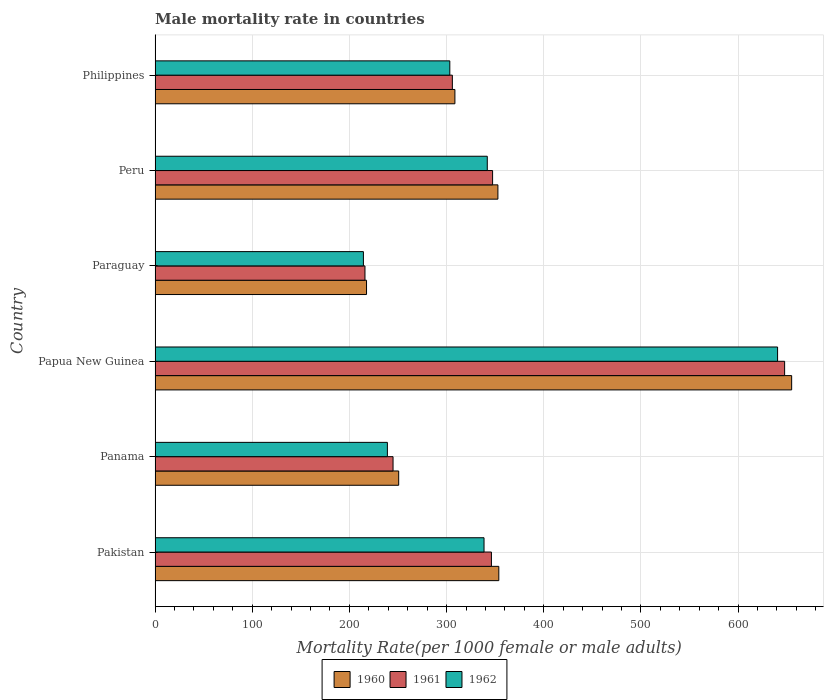How many groups of bars are there?
Make the answer very short. 6. Are the number of bars per tick equal to the number of legend labels?
Ensure brevity in your answer.  Yes. Are the number of bars on each tick of the Y-axis equal?
Give a very brief answer. Yes. What is the label of the 5th group of bars from the top?
Offer a terse response. Panama. What is the male mortality rate in 1960 in Peru?
Make the answer very short. 352.84. Across all countries, what is the maximum male mortality rate in 1961?
Keep it short and to the point. 647.91. Across all countries, what is the minimum male mortality rate in 1960?
Your response must be concise. 217.64. In which country was the male mortality rate in 1961 maximum?
Keep it short and to the point. Papua New Guinea. In which country was the male mortality rate in 1962 minimum?
Make the answer very short. Paraguay. What is the total male mortality rate in 1961 in the graph?
Your response must be concise. 2108.36. What is the difference between the male mortality rate in 1961 in Paraguay and that in Peru?
Offer a terse response. -131.34. What is the difference between the male mortality rate in 1961 in Panama and the male mortality rate in 1960 in Philippines?
Make the answer very short. -63.66. What is the average male mortality rate in 1960 per country?
Your answer should be very brief. 356.45. What is the difference between the male mortality rate in 1962 and male mortality rate in 1961 in Panama?
Your answer should be very brief. -5.82. In how many countries, is the male mortality rate in 1962 greater than 580 ?
Offer a very short reply. 1. What is the ratio of the male mortality rate in 1960 in Panama to that in Paraguay?
Offer a very short reply. 1.15. Is the male mortality rate in 1962 in Peru less than that in Philippines?
Your answer should be very brief. No. Is the difference between the male mortality rate in 1962 in Pakistan and Philippines greater than the difference between the male mortality rate in 1961 in Pakistan and Philippines?
Provide a short and direct response. No. What is the difference between the highest and the second highest male mortality rate in 1960?
Provide a succinct answer. 301.39. What is the difference between the highest and the lowest male mortality rate in 1962?
Provide a short and direct response. 426.24. Is the sum of the male mortality rate in 1962 in Paraguay and Philippines greater than the maximum male mortality rate in 1961 across all countries?
Your answer should be very brief. No. How many bars are there?
Ensure brevity in your answer.  18. Are all the bars in the graph horizontal?
Offer a very short reply. Yes. What is the difference between two consecutive major ticks on the X-axis?
Keep it short and to the point. 100. Are the values on the major ticks of X-axis written in scientific E-notation?
Your answer should be very brief. No. Does the graph contain grids?
Make the answer very short. Yes. How many legend labels are there?
Your answer should be compact. 3. How are the legend labels stacked?
Make the answer very short. Horizontal. What is the title of the graph?
Your response must be concise. Male mortality rate in countries. Does "2013" appear as one of the legend labels in the graph?
Offer a very short reply. No. What is the label or title of the X-axis?
Give a very brief answer. Mortality Rate(per 1000 female or male adults). What is the label or title of the Y-axis?
Keep it short and to the point. Country. What is the Mortality Rate(per 1000 female or male adults) of 1960 in Pakistan?
Offer a very short reply. 353.77. What is the Mortality Rate(per 1000 female or male adults) of 1961 in Pakistan?
Give a very brief answer. 346.17. What is the Mortality Rate(per 1000 female or male adults) of 1962 in Pakistan?
Offer a very short reply. 338.56. What is the Mortality Rate(per 1000 female or male adults) in 1960 in Panama?
Ensure brevity in your answer.  250.73. What is the Mortality Rate(per 1000 female or male adults) in 1961 in Panama?
Keep it short and to the point. 244.92. What is the Mortality Rate(per 1000 female or male adults) of 1962 in Panama?
Your response must be concise. 239.1. What is the Mortality Rate(per 1000 female or male adults) of 1960 in Papua New Guinea?
Offer a very short reply. 655.16. What is the Mortality Rate(per 1000 female or male adults) of 1961 in Papua New Guinea?
Provide a succinct answer. 647.91. What is the Mortality Rate(per 1000 female or male adults) in 1962 in Papua New Guinea?
Provide a succinct answer. 640.66. What is the Mortality Rate(per 1000 female or male adults) of 1960 in Paraguay?
Offer a very short reply. 217.64. What is the Mortality Rate(per 1000 female or male adults) of 1961 in Paraguay?
Give a very brief answer. 216.03. What is the Mortality Rate(per 1000 female or male adults) of 1962 in Paraguay?
Make the answer very short. 214.42. What is the Mortality Rate(per 1000 female or male adults) in 1960 in Peru?
Offer a very short reply. 352.84. What is the Mortality Rate(per 1000 female or male adults) in 1961 in Peru?
Your answer should be very brief. 347.37. What is the Mortality Rate(per 1000 female or male adults) in 1962 in Peru?
Ensure brevity in your answer.  341.9. What is the Mortality Rate(per 1000 female or male adults) of 1960 in Philippines?
Your answer should be compact. 308.58. What is the Mortality Rate(per 1000 female or male adults) in 1961 in Philippines?
Provide a short and direct response. 305.97. What is the Mortality Rate(per 1000 female or male adults) in 1962 in Philippines?
Provide a succinct answer. 303.35. Across all countries, what is the maximum Mortality Rate(per 1000 female or male adults) of 1960?
Ensure brevity in your answer.  655.16. Across all countries, what is the maximum Mortality Rate(per 1000 female or male adults) of 1961?
Provide a succinct answer. 647.91. Across all countries, what is the maximum Mortality Rate(per 1000 female or male adults) in 1962?
Your answer should be very brief. 640.66. Across all countries, what is the minimum Mortality Rate(per 1000 female or male adults) in 1960?
Offer a terse response. 217.64. Across all countries, what is the minimum Mortality Rate(per 1000 female or male adults) in 1961?
Your response must be concise. 216.03. Across all countries, what is the minimum Mortality Rate(per 1000 female or male adults) in 1962?
Your answer should be very brief. 214.42. What is the total Mortality Rate(per 1000 female or male adults) in 1960 in the graph?
Your response must be concise. 2138.72. What is the total Mortality Rate(per 1000 female or male adults) in 1961 in the graph?
Offer a very short reply. 2108.36. What is the total Mortality Rate(per 1000 female or male adults) in 1962 in the graph?
Offer a very short reply. 2078. What is the difference between the Mortality Rate(per 1000 female or male adults) in 1960 in Pakistan and that in Panama?
Your answer should be compact. 103.04. What is the difference between the Mortality Rate(per 1000 female or male adults) in 1961 in Pakistan and that in Panama?
Give a very brief answer. 101.25. What is the difference between the Mortality Rate(per 1000 female or male adults) in 1962 in Pakistan and that in Panama?
Offer a very short reply. 99.46. What is the difference between the Mortality Rate(per 1000 female or male adults) of 1960 in Pakistan and that in Papua New Guinea?
Provide a short and direct response. -301.39. What is the difference between the Mortality Rate(per 1000 female or male adults) of 1961 in Pakistan and that in Papua New Guinea?
Keep it short and to the point. -301.74. What is the difference between the Mortality Rate(per 1000 female or male adults) in 1962 in Pakistan and that in Papua New Guinea?
Make the answer very short. -302.1. What is the difference between the Mortality Rate(per 1000 female or male adults) of 1960 in Pakistan and that in Paraguay?
Your answer should be compact. 136.13. What is the difference between the Mortality Rate(per 1000 female or male adults) in 1961 in Pakistan and that in Paraguay?
Your answer should be very brief. 130.13. What is the difference between the Mortality Rate(per 1000 female or male adults) in 1962 in Pakistan and that in Paraguay?
Your response must be concise. 124.14. What is the difference between the Mortality Rate(per 1000 female or male adults) of 1960 in Pakistan and that in Peru?
Ensure brevity in your answer.  0.93. What is the difference between the Mortality Rate(per 1000 female or male adults) in 1961 in Pakistan and that in Peru?
Your answer should be very brief. -1.2. What is the difference between the Mortality Rate(per 1000 female or male adults) of 1962 in Pakistan and that in Peru?
Ensure brevity in your answer.  -3.33. What is the difference between the Mortality Rate(per 1000 female or male adults) of 1960 in Pakistan and that in Philippines?
Provide a succinct answer. 45.19. What is the difference between the Mortality Rate(per 1000 female or male adults) of 1961 in Pakistan and that in Philippines?
Offer a very short reply. 40.2. What is the difference between the Mortality Rate(per 1000 female or male adults) in 1962 in Pakistan and that in Philippines?
Offer a very short reply. 35.21. What is the difference between the Mortality Rate(per 1000 female or male adults) of 1960 in Panama and that in Papua New Guinea?
Your answer should be compact. -404.42. What is the difference between the Mortality Rate(per 1000 female or male adults) of 1961 in Panama and that in Papua New Guinea?
Offer a very short reply. -402.99. What is the difference between the Mortality Rate(per 1000 female or male adults) of 1962 in Panama and that in Papua New Guinea?
Provide a short and direct response. -401.56. What is the difference between the Mortality Rate(per 1000 female or male adults) in 1960 in Panama and that in Paraguay?
Your answer should be compact. 33.09. What is the difference between the Mortality Rate(per 1000 female or male adults) of 1961 in Panama and that in Paraguay?
Your response must be concise. 28.89. What is the difference between the Mortality Rate(per 1000 female or male adults) of 1962 in Panama and that in Paraguay?
Give a very brief answer. 24.68. What is the difference between the Mortality Rate(per 1000 female or male adults) of 1960 in Panama and that in Peru?
Your answer should be compact. -102.1. What is the difference between the Mortality Rate(per 1000 female or male adults) of 1961 in Panama and that in Peru?
Offer a terse response. -102.45. What is the difference between the Mortality Rate(per 1000 female or male adults) in 1962 in Panama and that in Peru?
Ensure brevity in your answer.  -102.79. What is the difference between the Mortality Rate(per 1000 female or male adults) of 1960 in Panama and that in Philippines?
Offer a very short reply. -57.85. What is the difference between the Mortality Rate(per 1000 female or male adults) of 1961 in Panama and that in Philippines?
Provide a succinct answer. -61.05. What is the difference between the Mortality Rate(per 1000 female or male adults) of 1962 in Panama and that in Philippines?
Your answer should be compact. -64.25. What is the difference between the Mortality Rate(per 1000 female or male adults) in 1960 in Papua New Guinea and that in Paraguay?
Provide a short and direct response. 437.52. What is the difference between the Mortality Rate(per 1000 female or male adults) in 1961 in Papua New Guinea and that in Paraguay?
Keep it short and to the point. 431.88. What is the difference between the Mortality Rate(per 1000 female or male adults) in 1962 in Papua New Guinea and that in Paraguay?
Your response must be concise. 426.24. What is the difference between the Mortality Rate(per 1000 female or male adults) of 1960 in Papua New Guinea and that in Peru?
Make the answer very short. 302.32. What is the difference between the Mortality Rate(per 1000 female or male adults) of 1961 in Papua New Guinea and that in Peru?
Keep it short and to the point. 300.54. What is the difference between the Mortality Rate(per 1000 female or male adults) in 1962 in Papua New Guinea and that in Peru?
Provide a short and direct response. 298.77. What is the difference between the Mortality Rate(per 1000 female or male adults) in 1960 in Papua New Guinea and that in Philippines?
Offer a terse response. 346.57. What is the difference between the Mortality Rate(per 1000 female or male adults) in 1961 in Papua New Guinea and that in Philippines?
Give a very brief answer. 341.94. What is the difference between the Mortality Rate(per 1000 female or male adults) of 1962 in Papua New Guinea and that in Philippines?
Keep it short and to the point. 337.31. What is the difference between the Mortality Rate(per 1000 female or male adults) of 1960 in Paraguay and that in Peru?
Ensure brevity in your answer.  -135.2. What is the difference between the Mortality Rate(per 1000 female or male adults) of 1961 in Paraguay and that in Peru?
Your answer should be very brief. -131.34. What is the difference between the Mortality Rate(per 1000 female or male adults) of 1962 in Paraguay and that in Peru?
Offer a terse response. -127.48. What is the difference between the Mortality Rate(per 1000 female or male adults) of 1960 in Paraguay and that in Philippines?
Ensure brevity in your answer.  -90.94. What is the difference between the Mortality Rate(per 1000 female or male adults) of 1961 in Paraguay and that in Philippines?
Your answer should be very brief. -89.94. What is the difference between the Mortality Rate(per 1000 female or male adults) of 1962 in Paraguay and that in Philippines?
Your answer should be very brief. -88.93. What is the difference between the Mortality Rate(per 1000 female or male adults) of 1960 in Peru and that in Philippines?
Offer a very short reply. 44.26. What is the difference between the Mortality Rate(per 1000 female or male adults) of 1961 in Peru and that in Philippines?
Keep it short and to the point. 41.4. What is the difference between the Mortality Rate(per 1000 female or male adults) in 1962 in Peru and that in Philippines?
Your answer should be compact. 38.55. What is the difference between the Mortality Rate(per 1000 female or male adults) of 1960 in Pakistan and the Mortality Rate(per 1000 female or male adults) of 1961 in Panama?
Provide a short and direct response. 108.85. What is the difference between the Mortality Rate(per 1000 female or male adults) in 1960 in Pakistan and the Mortality Rate(per 1000 female or male adults) in 1962 in Panama?
Provide a succinct answer. 114.67. What is the difference between the Mortality Rate(per 1000 female or male adults) of 1961 in Pakistan and the Mortality Rate(per 1000 female or male adults) of 1962 in Panama?
Offer a terse response. 107.06. What is the difference between the Mortality Rate(per 1000 female or male adults) in 1960 in Pakistan and the Mortality Rate(per 1000 female or male adults) in 1961 in Papua New Guinea?
Provide a succinct answer. -294.14. What is the difference between the Mortality Rate(per 1000 female or male adults) of 1960 in Pakistan and the Mortality Rate(per 1000 female or male adults) of 1962 in Papua New Guinea?
Give a very brief answer. -286.89. What is the difference between the Mortality Rate(per 1000 female or male adults) of 1961 in Pakistan and the Mortality Rate(per 1000 female or male adults) of 1962 in Papua New Guinea?
Your answer should be compact. -294.5. What is the difference between the Mortality Rate(per 1000 female or male adults) in 1960 in Pakistan and the Mortality Rate(per 1000 female or male adults) in 1961 in Paraguay?
Offer a very short reply. 137.74. What is the difference between the Mortality Rate(per 1000 female or male adults) in 1960 in Pakistan and the Mortality Rate(per 1000 female or male adults) in 1962 in Paraguay?
Your response must be concise. 139.35. What is the difference between the Mortality Rate(per 1000 female or male adults) in 1961 in Pakistan and the Mortality Rate(per 1000 female or male adults) in 1962 in Paraguay?
Make the answer very short. 131.75. What is the difference between the Mortality Rate(per 1000 female or male adults) of 1960 in Pakistan and the Mortality Rate(per 1000 female or male adults) of 1961 in Peru?
Offer a terse response. 6.4. What is the difference between the Mortality Rate(per 1000 female or male adults) in 1960 in Pakistan and the Mortality Rate(per 1000 female or male adults) in 1962 in Peru?
Offer a terse response. 11.87. What is the difference between the Mortality Rate(per 1000 female or male adults) in 1961 in Pakistan and the Mortality Rate(per 1000 female or male adults) in 1962 in Peru?
Your answer should be very brief. 4.27. What is the difference between the Mortality Rate(per 1000 female or male adults) in 1960 in Pakistan and the Mortality Rate(per 1000 female or male adults) in 1961 in Philippines?
Your answer should be very brief. 47.8. What is the difference between the Mortality Rate(per 1000 female or male adults) in 1960 in Pakistan and the Mortality Rate(per 1000 female or male adults) in 1962 in Philippines?
Provide a short and direct response. 50.42. What is the difference between the Mortality Rate(per 1000 female or male adults) in 1961 in Pakistan and the Mortality Rate(per 1000 female or male adults) in 1962 in Philippines?
Ensure brevity in your answer.  42.81. What is the difference between the Mortality Rate(per 1000 female or male adults) of 1960 in Panama and the Mortality Rate(per 1000 female or male adults) of 1961 in Papua New Guinea?
Keep it short and to the point. -397.18. What is the difference between the Mortality Rate(per 1000 female or male adults) of 1960 in Panama and the Mortality Rate(per 1000 female or male adults) of 1962 in Papua New Guinea?
Provide a succinct answer. -389.93. What is the difference between the Mortality Rate(per 1000 female or male adults) of 1961 in Panama and the Mortality Rate(per 1000 female or male adults) of 1962 in Papua New Guinea?
Ensure brevity in your answer.  -395.74. What is the difference between the Mortality Rate(per 1000 female or male adults) in 1960 in Panama and the Mortality Rate(per 1000 female or male adults) in 1961 in Paraguay?
Give a very brief answer. 34.7. What is the difference between the Mortality Rate(per 1000 female or male adults) in 1960 in Panama and the Mortality Rate(per 1000 female or male adults) in 1962 in Paraguay?
Your response must be concise. 36.31. What is the difference between the Mortality Rate(per 1000 female or male adults) of 1961 in Panama and the Mortality Rate(per 1000 female or male adults) of 1962 in Paraguay?
Make the answer very short. 30.5. What is the difference between the Mortality Rate(per 1000 female or male adults) of 1960 in Panama and the Mortality Rate(per 1000 female or male adults) of 1961 in Peru?
Your answer should be compact. -96.63. What is the difference between the Mortality Rate(per 1000 female or male adults) in 1960 in Panama and the Mortality Rate(per 1000 female or male adults) in 1962 in Peru?
Offer a very short reply. -91.16. What is the difference between the Mortality Rate(per 1000 female or male adults) in 1961 in Panama and the Mortality Rate(per 1000 female or male adults) in 1962 in Peru?
Your answer should be compact. -96.98. What is the difference between the Mortality Rate(per 1000 female or male adults) in 1960 in Panama and the Mortality Rate(per 1000 female or male adults) in 1961 in Philippines?
Provide a succinct answer. -55.23. What is the difference between the Mortality Rate(per 1000 female or male adults) in 1960 in Panama and the Mortality Rate(per 1000 female or male adults) in 1962 in Philippines?
Ensure brevity in your answer.  -52.62. What is the difference between the Mortality Rate(per 1000 female or male adults) in 1961 in Panama and the Mortality Rate(per 1000 female or male adults) in 1962 in Philippines?
Offer a very short reply. -58.43. What is the difference between the Mortality Rate(per 1000 female or male adults) in 1960 in Papua New Guinea and the Mortality Rate(per 1000 female or male adults) in 1961 in Paraguay?
Ensure brevity in your answer.  439.13. What is the difference between the Mortality Rate(per 1000 female or male adults) of 1960 in Papua New Guinea and the Mortality Rate(per 1000 female or male adults) of 1962 in Paraguay?
Your response must be concise. 440.74. What is the difference between the Mortality Rate(per 1000 female or male adults) of 1961 in Papua New Guinea and the Mortality Rate(per 1000 female or male adults) of 1962 in Paraguay?
Keep it short and to the point. 433.49. What is the difference between the Mortality Rate(per 1000 female or male adults) of 1960 in Papua New Guinea and the Mortality Rate(per 1000 female or male adults) of 1961 in Peru?
Keep it short and to the point. 307.79. What is the difference between the Mortality Rate(per 1000 female or male adults) in 1960 in Papua New Guinea and the Mortality Rate(per 1000 female or male adults) in 1962 in Peru?
Your answer should be compact. 313.26. What is the difference between the Mortality Rate(per 1000 female or male adults) of 1961 in Papua New Guinea and the Mortality Rate(per 1000 female or male adults) of 1962 in Peru?
Your answer should be compact. 306.01. What is the difference between the Mortality Rate(per 1000 female or male adults) of 1960 in Papua New Guinea and the Mortality Rate(per 1000 female or male adults) of 1961 in Philippines?
Your answer should be compact. 349.19. What is the difference between the Mortality Rate(per 1000 female or male adults) in 1960 in Papua New Guinea and the Mortality Rate(per 1000 female or male adults) in 1962 in Philippines?
Provide a short and direct response. 351.81. What is the difference between the Mortality Rate(per 1000 female or male adults) of 1961 in Papua New Guinea and the Mortality Rate(per 1000 female or male adults) of 1962 in Philippines?
Offer a very short reply. 344.56. What is the difference between the Mortality Rate(per 1000 female or male adults) of 1960 in Paraguay and the Mortality Rate(per 1000 female or male adults) of 1961 in Peru?
Provide a short and direct response. -129.73. What is the difference between the Mortality Rate(per 1000 female or male adults) of 1960 in Paraguay and the Mortality Rate(per 1000 female or male adults) of 1962 in Peru?
Ensure brevity in your answer.  -124.26. What is the difference between the Mortality Rate(per 1000 female or male adults) in 1961 in Paraguay and the Mortality Rate(per 1000 female or male adults) in 1962 in Peru?
Your answer should be very brief. -125.87. What is the difference between the Mortality Rate(per 1000 female or male adults) of 1960 in Paraguay and the Mortality Rate(per 1000 female or male adults) of 1961 in Philippines?
Your response must be concise. -88.33. What is the difference between the Mortality Rate(per 1000 female or male adults) in 1960 in Paraguay and the Mortality Rate(per 1000 female or male adults) in 1962 in Philippines?
Offer a very short reply. -85.71. What is the difference between the Mortality Rate(per 1000 female or male adults) of 1961 in Paraguay and the Mortality Rate(per 1000 female or male adults) of 1962 in Philippines?
Make the answer very short. -87.32. What is the difference between the Mortality Rate(per 1000 female or male adults) in 1960 in Peru and the Mortality Rate(per 1000 female or male adults) in 1961 in Philippines?
Offer a very short reply. 46.87. What is the difference between the Mortality Rate(per 1000 female or male adults) of 1960 in Peru and the Mortality Rate(per 1000 female or male adults) of 1962 in Philippines?
Provide a short and direct response. 49.49. What is the difference between the Mortality Rate(per 1000 female or male adults) of 1961 in Peru and the Mortality Rate(per 1000 female or male adults) of 1962 in Philippines?
Offer a very short reply. 44.02. What is the average Mortality Rate(per 1000 female or male adults) of 1960 per country?
Your answer should be very brief. 356.45. What is the average Mortality Rate(per 1000 female or male adults) of 1961 per country?
Provide a succinct answer. 351.39. What is the average Mortality Rate(per 1000 female or male adults) in 1962 per country?
Make the answer very short. 346.33. What is the difference between the Mortality Rate(per 1000 female or male adults) in 1960 and Mortality Rate(per 1000 female or male adults) in 1961 in Pakistan?
Ensure brevity in your answer.  7.61. What is the difference between the Mortality Rate(per 1000 female or male adults) in 1960 and Mortality Rate(per 1000 female or male adults) in 1962 in Pakistan?
Provide a succinct answer. 15.21. What is the difference between the Mortality Rate(per 1000 female or male adults) of 1961 and Mortality Rate(per 1000 female or male adults) of 1962 in Pakistan?
Offer a very short reply. 7.6. What is the difference between the Mortality Rate(per 1000 female or male adults) of 1960 and Mortality Rate(per 1000 female or male adults) of 1961 in Panama?
Make the answer very short. 5.82. What is the difference between the Mortality Rate(per 1000 female or male adults) of 1960 and Mortality Rate(per 1000 female or male adults) of 1962 in Panama?
Your response must be concise. 11.63. What is the difference between the Mortality Rate(per 1000 female or male adults) in 1961 and Mortality Rate(per 1000 female or male adults) in 1962 in Panama?
Offer a very short reply. 5.82. What is the difference between the Mortality Rate(per 1000 female or male adults) of 1960 and Mortality Rate(per 1000 female or male adults) of 1961 in Papua New Guinea?
Make the answer very short. 7.25. What is the difference between the Mortality Rate(per 1000 female or male adults) in 1960 and Mortality Rate(per 1000 female or male adults) in 1962 in Papua New Guinea?
Your answer should be very brief. 14.49. What is the difference between the Mortality Rate(per 1000 female or male adults) in 1961 and Mortality Rate(per 1000 female or male adults) in 1962 in Papua New Guinea?
Provide a succinct answer. 7.25. What is the difference between the Mortality Rate(per 1000 female or male adults) of 1960 and Mortality Rate(per 1000 female or male adults) of 1961 in Paraguay?
Ensure brevity in your answer.  1.61. What is the difference between the Mortality Rate(per 1000 female or male adults) in 1960 and Mortality Rate(per 1000 female or male adults) in 1962 in Paraguay?
Keep it short and to the point. 3.22. What is the difference between the Mortality Rate(per 1000 female or male adults) of 1961 and Mortality Rate(per 1000 female or male adults) of 1962 in Paraguay?
Provide a short and direct response. 1.61. What is the difference between the Mortality Rate(per 1000 female or male adults) in 1960 and Mortality Rate(per 1000 female or male adults) in 1961 in Peru?
Your answer should be very brief. 5.47. What is the difference between the Mortality Rate(per 1000 female or male adults) of 1960 and Mortality Rate(per 1000 female or male adults) of 1962 in Peru?
Keep it short and to the point. 10.94. What is the difference between the Mortality Rate(per 1000 female or male adults) in 1961 and Mortality Rate(per 1000 female or male adults) in 1962 in Peru?
Keep it short and to the point. 5.47. What is the difference between the Mortality Rate(per 1000 female or male adults) in 1960 and Mortality Rate(per 1000 female or male adults) in 1961 in Philippines?
Ensure brevity in your answer.  2.62. What is the difference between the Mortality Rate(per 1000 female or male adults) of 1960 and Mortality Rate(per 1000 female or male adults) of 1962 in Philippines?
Give a very brief answer. 5.23. What is the difference between the Mortality Rate(per 1000 female or male adults) in 1961 and Mortality Rate(per 1000 female or male adults) in 1962 in Philippines?
Your response must be concise. 2.62. What is the ratio of the Mortality Rate(per 1000 female or male adults) in 1960 in Pakistan to that in Panama?
Make the answer very short. 1.41. What is the ratio of the Mortality Rate(per 1000 female or male adults) in 1961 in Pakistan to that in Panama?
Your answer should be compact. 1.41. What is the ratio of the Mortality Rate(per 1000 female or male adults) of 1962 in Pakistan to that in Panama?
Provide a succinct answer. 1.42. What is the ratio of the Mortality Rate(per 1000 female or male adults) of 1960 in Pakistan to that in Papua New Guinea?
Keep it short and to the point. 0.54. What is the ratio of the Mortality Rate(per 1000 female or male adults) in 1961 in Pakistan to that in Papua New Guinea?
Ensure brevity in your answer.  0.53. What is the ratio of the Mortality Rate(per 1000 female or male adults) of 1962 in Pakistan to that in Papua New Guinea?
Your answer should be very brief. 0.53. What is the ratio of the Mortality Rate(per 1000 female or male adults) of 1960 in Pakistan to that in Paraguay?
Your answer should be very brief. 1.63. What is the ratio of the Mortality Rate(per 1000 female or male adults) in 1961 in Pakistan to that in Paraguay?
Your answer should be compact. 1.6. What is the ratio of the Mortality Rate(per 1000 female or male adults) in 1962 in Pakistan to that in Paraguay?
Your answer should be very brief. 1.58. What is the ratio of the Mortality Rate(per 1000 female or male adults) of 1960 in Pakistan to that in Peru?
Give a very brief answer. 1. What is the ratio of the Mortality Rate(per 1000 female or male adults) in 1962 in Pakistan to that in Peru?
Offer a terse response. 0.99. What is the ratio of the Mortality Rate(per 1000 female or male adults) in 1960 in Pakistan to that in Philippines?
Offer a very short reply. 1.15. What is the ratio of the Mortality Rate(per 1000 female or male adults) of 1961 in Pakistan to that in Philippines?
Your answer should be compact. 1.13. What is the ratio of the Mortality Rate(per 1000 female or male adults) of 1962 in Pakistan to that in Philippines?
Make the answer very short. 1.12. What is the ratio of the Mortality Rate(per 1000 female or male adults) in 1960 in Panama to that in Papua New Guinea?
Give a very brief answer. 0.38. What is the ratio of the Mortality Rate(per 1000 female or male adults) in 1961 in Panama to that in Papua New Guinea?
Make the answer very short. 0.38. What is the ratio of the Mortality Rate(per 1000 female or male adults) in 1962 in Panama to that in Papua New Guinea?
Your answer should be compact. 0.37. What is the ratio of the Mortality Rate(per 1000 female or male adults) in 1960 in Panama to that in Paraguay?
Offer a very short reply. 1.15. What is the ratio of the Mortality Rate(per 1000 female or male adults) in 1961 in Panama to that in Paraguay?
Offer a terse response. 1.13. What is the ratio of the Mortality Rate(per 1000 female or male adults) of 1962 in Panama to that in Paraguay?
Your answer should be very brief. 1.12. What is the ratio of the Mortality Rate(per 1000 female or male adults) in 1960 in Panama to that in Peru?
Give a very brief answer. 0.71. What is the ratio of the Mortality Rate(per 1000 female or male adults) of 1961 in Panama to that in Peru?
Make the answer very short. 0.71. What is the ratio of the Mortality Rate(per 1000 female or male adults) in 1962 in Panama to that in Peru?
Provide a succinct answer. 0.7. What is the ratio of the Mortality Rate(per 1000 female or male adults) of 1960 in Panama to that in Philippines?
Provide a short and direct response. 0.81. What is the ratio of the Mortality Rate(per 1000 female or male adults) in 1961 in Panama to that in Philippines?
Give a very brief answer. 0.8. What is the ratio of the Mortality Rate(per 1000 female or male adults) of 1962 in Panama to that in Philippines?
Offer a terse response. 0.79. What is the ratio of the Mortality Rate(per 1000 female or male adults) of 1960 in Papua New Guinea to that in Paraguay?
Ensure brevity in your answer.  3.01. What is the ratio of the Mortality Rate(per 1000 female or male adults) in 1961 in Papua New Guinea to that in Paraguay?
Keep it short and to the point. 3. What is the ratio of the Mortality Rate(per 1000 female or male adults) in 1962 in Papua New Guinea to that in Paraguay?
Your answer should be very brief. 2.99. What is the ratio of the Mortality Rate(per 1000 female or male adults) in 1960 in Papua New Guinea to that in Peru?
Offer a terse response. 1.86. What is the ratio of the Mortality Rate(per 1000 female or male adults) in 1961 in Papua New Guinea to that in Peru?
Provide a short and direct response. 1.87. What is the ratio of the Mortality Rate(per 1000 female or male adults) of 1962 in Papua New Guinea to that in Peru?
Your answer should be compact. 1.87. What is the ratio of the Mortality Rate(per 1000 female or male adults) of 1960 in Papua New Guinea to that in Philippines?
Offer a very short reply. 2.12. What is the ratio of the Mortality Rate(per 1000 female or male adults) of 1961 in Papua New Guinea to that in Philippines?
Provide a short and direct response. 2.12. What is the ratio of the Mortality Rate(per 1000 female or male adults) of 1962 in Papua New Guinea to that in Philippines?
Keep it short and to the point. 2.11. What is the ratio of the Mortality Rate(per 1000 female or male adults) of 1960 in Paraguay to that in Peru?
Ensure brevity in your answer.  0.62. What is the ratio of the Mortality Rate(per 1000 female or male adults) in 1961 in Paraguay to that in Peru?
Give a very brief answer. 0.62. What is the ratio of the Mortality Rate(per 1000 female or male adults) of 1962 in Paraguay to that in Peru?
Give a very brief answer. 0.63. What is the ratio of the Mortality Rate(per 1000 female or male adults) in 1960 in Paraguay to that in Philippines?
Offer a terse response. 0.71. What is the ratio of the Mortality Rate(per 1000 female or male adults) of 1961 in Paraguay to that in Philippines?
Offer a very short reply. 0.71. What is the ratio of the Mortality Rate(per 1000 female or male adults) of 1962 in Paraguay to that in Philippines?
Give a very brief answer. 0.71. What is the ratio of the Mortality Rate(per 1000 female or male adults) in 1960 in Peru to that in Philippines?
Ensure brevity in your answer.  1.14. What is the ratio of the Mortality Rate(per 1000 female or male adults) of 1961 in Peru to that in Philippines?
Provide a short and direct response. 1.14. What is the ratio of the Mortality Rate(per 1000 female or male adults) in 1962 in Peru to that in Philippines?
Keep it short and to the point. 1.13. What is the difference between the highest and the second highest Mortality Rate(per 1000 female or male adults) in 1960?
Your answer should be very brief. 301.39. What is the difference between the highest and the second highest Mortality Rate(per 1000 female or male adults) of 1961?
Make the answer very short. 300.54. What is the difference between the highest and the second highest Mortality Rate(per 1000 female or male adults) of 1962?
Keep it short and to the point. 298.77. What is the difference between the highest and the lowest Mortality Rate(per 1000 female or male adults) of 1960?
Offer a very short reply. 437.52. What is the difference between the highest and the lowest Mortality Rate(per 1000 female or male adults) in 1961?
Offer a terse response. 431.88. What is the difference between the highest and the lowest Mortality Rate(per 1000 female or male adults) of 1962?
Keep it short and to the point. 426.24. 